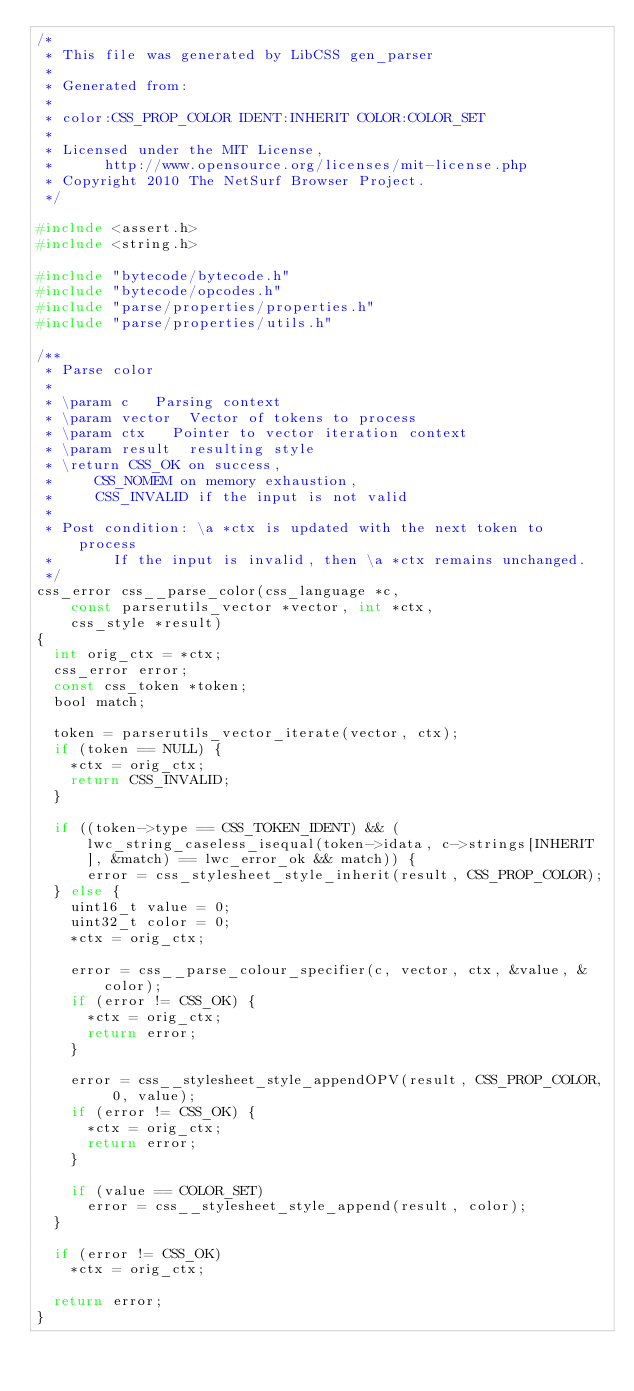Convert code to text. <code><loc_0><loc_0><loc_500><loc_500><_C_>/*
 * This file was generated by LibCSS gen_parser 
 * 
 * Generated from:
 *
 * color:CSS_PROP_COLOR IDENT:INHERIT COLOR:COLOR_SET
 * 
 * Licensed under the MIT License,
 *		  http://www.opensource.org/licenses/mit-license.php
 * Copyright 2010 The NetSurf Browser Project.
 */

#include <assert.h>
#include <string.h>

#include "bytecode/bytecode.h"
#include "bytecode/opcodes.h"
#include "parse/properties/properties.h"
#include "parse/properties/utils.h"

/**
 * Parse color
 *
 * \param c	  Parsing context
 * \param vector  Vector of tokens to process
 * \param ctx	  Pointer to vector iteration context
 * \param result  resulting style
 * \return CSS_OK on success,
 *	   CSS_NOMEM on memory exhaustion,
 *	   CSS_INVALID if the input is not valid
 *
 * Post condition: \a *ctx is updated with the next token to process
 *		   If the input is invalid, then \a *ctx remains unchanged.
 */
css_error css__parse_color(css_language *c,
		const parserutils_vector *vector, int *ctx,
		css_style *result)
{
	int orig_ctx = *ctx;
	css_error error;
	const css_token *token;
	bool match;

	token = parserutils_vector_iterate(vector, ctx);
	if (token == NULL) {
		*ctx = orig_ctx;
		return CSS_INVALID;
	}

	if ((token->type == CSS_TOKEN_IDENT) && (lwc_string_caseless_isequal(token->idata, c->strings[INHERIT], &match) == lwc_error_ok && match)) {
			error = css_stylesheet_style_inherit(result, CSS_PROP_COLOR);
	} else {
		uint16_t value = 0;
		uint32_t color = 0;
		*ctx = orig_ctx;

		error = css__parse_colour_specifier(c, vector, ctx, &value, &color);
		if (error != CSS_OK) {
			*ctx = orig_ctx;
			return error;
		}

		error = css__stylesheet_style_appendOPV(result, CSS_PROP_COLOR, 0, value);
		if (error != CSS_OK) {
			*ctx = orig_ctx;
			return error;
		}

		if (value == COLOR_SET)
			error = css__stylesheet_style_append(result, color);
	}

	if (error != CSS_OK)
		*ctx = orig_ctx;
	
	return error;
}

</code> 